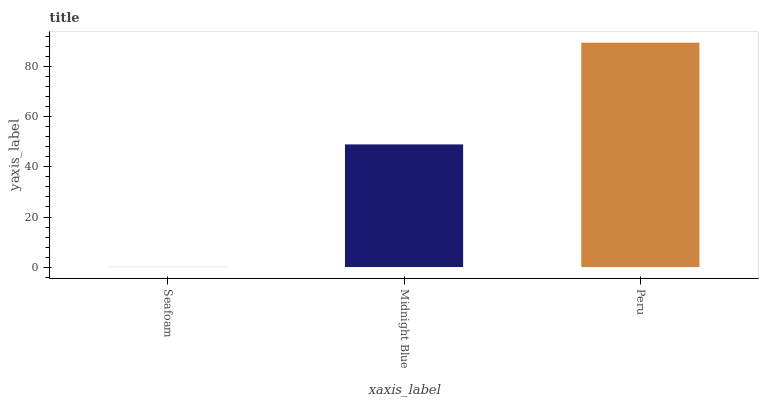Is Seafoam the minimum?
Answer yes or no. Yes. Is Peru the maximum?
Answer yes or no. Yes. Is Midnight Blue the minimum?
Answer yes or no. No. Is Midnight Blue the maximum?
Answer yes or no. No. Is Midnight Blue greater than Seafoam?
Answer yes or no. Yes. Is Seafoam less than Midnight Blue?
Answer yes or no. Yes. Is Seafoam greater than Midnight Blue?
Answer yes or no. No. Is Midnight Blue less than Seafoam?
Answer yes or no. No. Is Midnight Blue the high median?
Answer yes or no. Yes. Is Midnight Blue the low median?
Answer yes or no. Yes. Is Seafoam the high median?
Answer yes or no. No. Is Seafoam the low median?
Answer yes or no. No. 